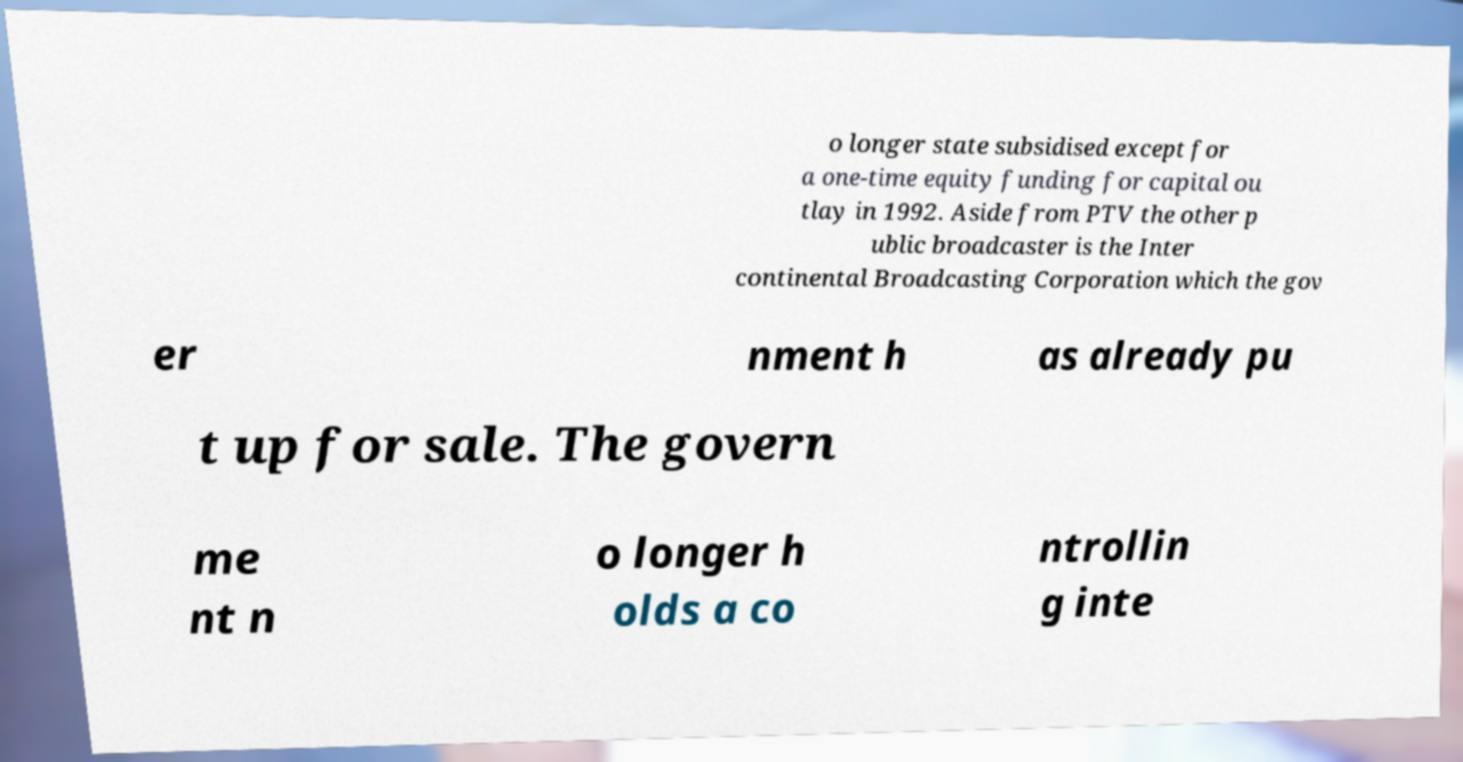Please read and relay the text visible in this image. What does it say? o longer state subsidised except for a one-time equity funding for capital ou tlay in 1992. Aside from PTV the other p ublic broadcaster is the Inter continental Broadcasting Corporation which the gov er nment h as already pu t up for sale. The govern me nt n o longer h olds a co ntrollin g inte 